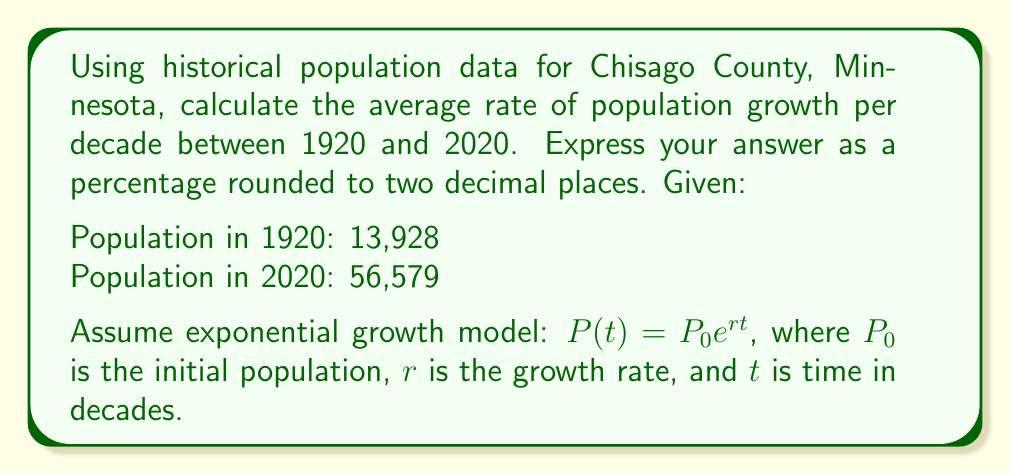Solve this math problem. Let's approach this step-by-step:

1) We'll use the exponential growth formula: $P(t) = P_0 e^{rt}$

2) We know:
   $P_0 = 13,928$ (population in 1920)
   $P(10) = 56,579$ (population in 2020, 10 decades later)
   $t = 10$ (number of decades)

3) Plug these into the formula:
   $56,579 = 13,928 e^{10r}$

4) Divide both sides by 13,928:
   $\frac{56,579}{13,928} = e^{10r}$

5) Take the natural log of both sides:
   $\ln(\frac{56,579}{13,928}) = 10r$

6) Solve for $r$:
   $r = \frac{\ln(\frac{56,579}{13,928})}{10}$

7) Calculate:
   $r = \frac{\ln(4.0623)}{10} = \frac{1.4018}{10} = 0.14018$

8) Convert to percentage and round to two decimal places:
   $0.14018 * 100 = 14.02\%$

This means the population grew by an average of 14.02% per decade.
Answer: 14.02% 